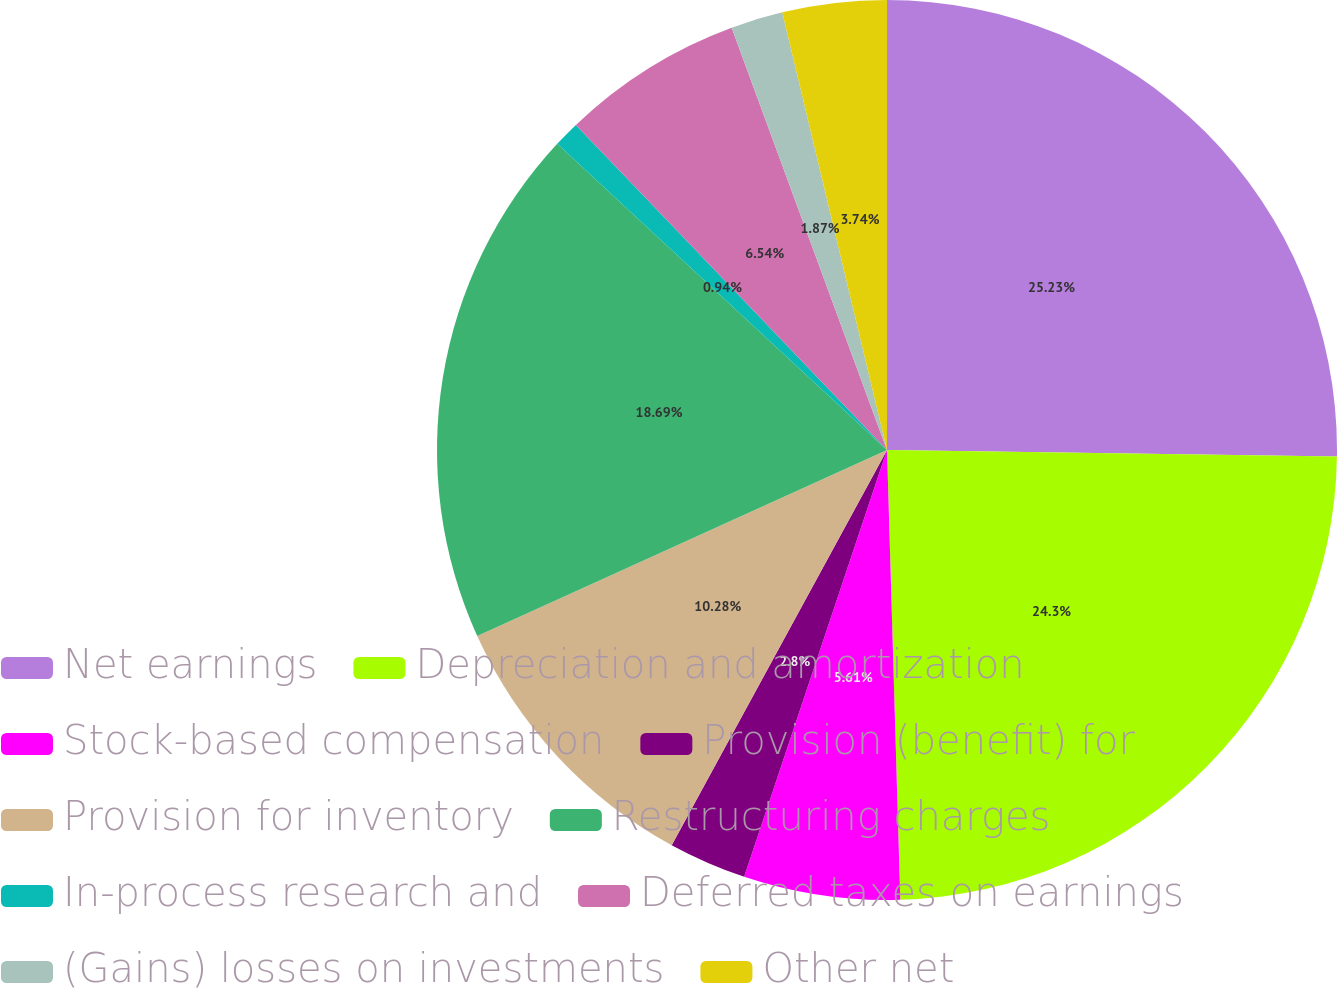<chart> <loc_0><loc_0><loc_500><loc_500><pie_chart><fcel>Net earnings<fcel>Depreciation and amortization<fcel>Stock-based compensation<fcel>Provision (benefit) for<fcel>Provision for inventory<fcel>Restructuring charges<fcel>In-process research and<fcel>Deferred taxes on earnings<fcel>(Gains) losses on investments<fcel>Other net<nl><fcel>25.23%<fcel>24.3%<fcel>5.61%<fcel>2.8%<fcel>10.28%<fcel>18.69%<fcel>0.94%<fcel>6.54%<fcel>1.87%<fcel>3.74%<nl></chart> 